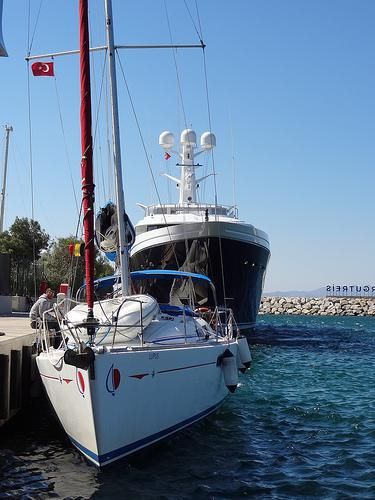Question: where is the picture taken?
Choices:
A. On the dock.
B. On a mountain.
C. At a farm.
D. At the zoo.
Answer with the letter. Answer: A Question: why boat not moving?
Choices:
A. Docked at pier.
B. Anchored.
C. Drydocked.
D. No wind.
Answer with the letter. Answer: A Question: what color is small boat?
Choices:
A. White.
B. Black.
C. Red.
D. Blue.
Answer with the letter. Answer: A Question: what color is large boat?
Choices:
A. Red.
B. Black.
C. Green.
D. Gray.
Answer with the letter. Answer: B 